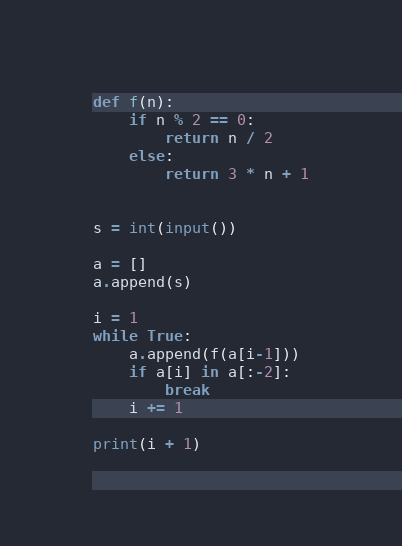Convert code to text. <code><loc_0><loc_0><loc_500><loc_500><_Python_>def f(n):
    if n % 2 == 0:
        return n / 2
    else:
        return 3 * n + 1


s = int(input())

a = []
a.append(s)

i = 1
while True:
    a.append(f(a[i-1]))
    if a[i] in a[:-2]:
        break
    i += 1

print(i + 1)
</code> 